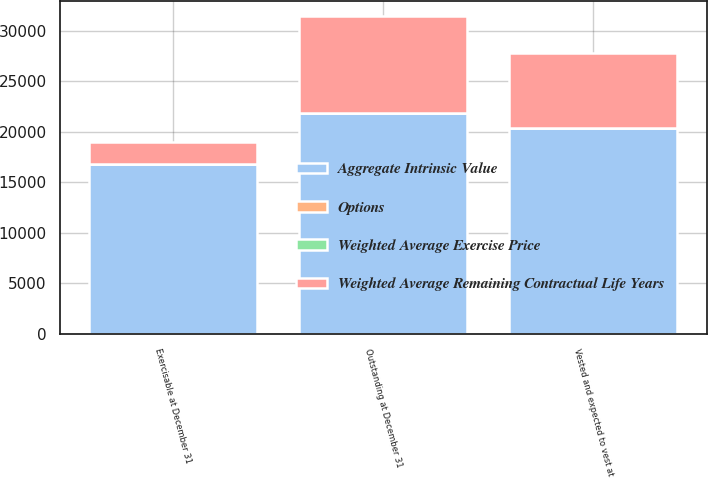Convert chart. <chart><loc_0><loc_0><loc_500><loc_500><stacked_bar_chart><ecel><fcel>Outstanding at December 31<fcel>Vested and expected to vest at<fcel>Exercisable at December 31<nl><fcel>Aggregate Intrinsic Value<fcel>21862<fcel>20367<fcel>16829<nl><fcel>Options<fcel>15.96<fcel>16.73<fcel>19.11<nl><fcel>Weighted Average Exercise Price<fcel>3<fcel>2.8<fcel>2.1<nl><fcel>Weighted Average Remaining Contractual Life Years<fcel>9533<fcel>7392<fcel>2110<nl></chart> 